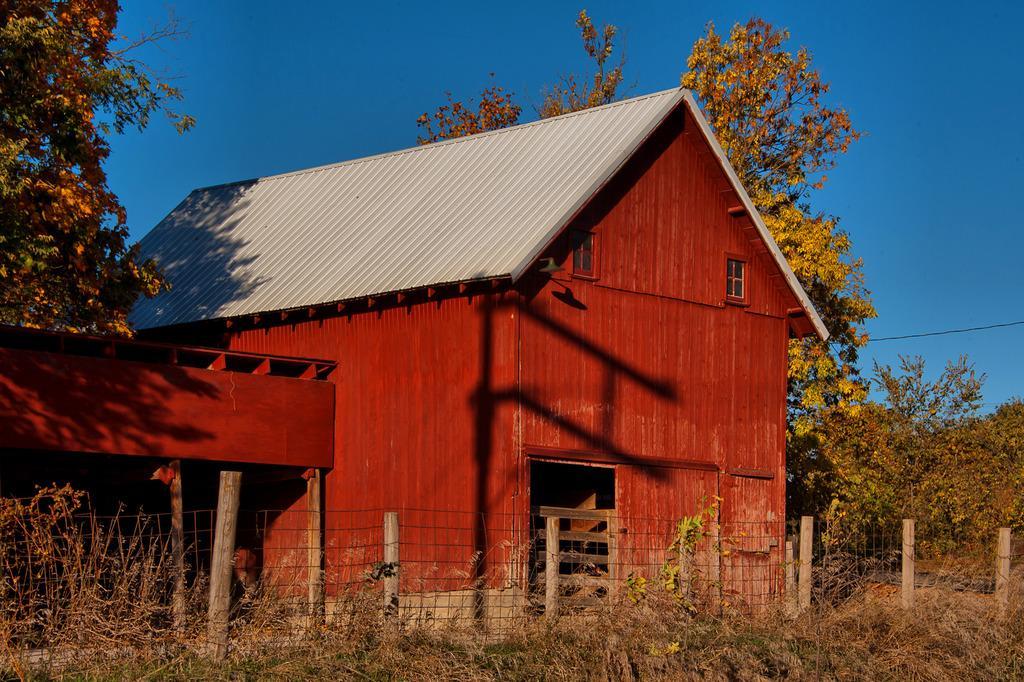Could you give a brief overview of what you see in this image? In this image in the center there is one house, at the bottom there is a fence, wooden poles and some grass. In the background there are some trees and sky. 